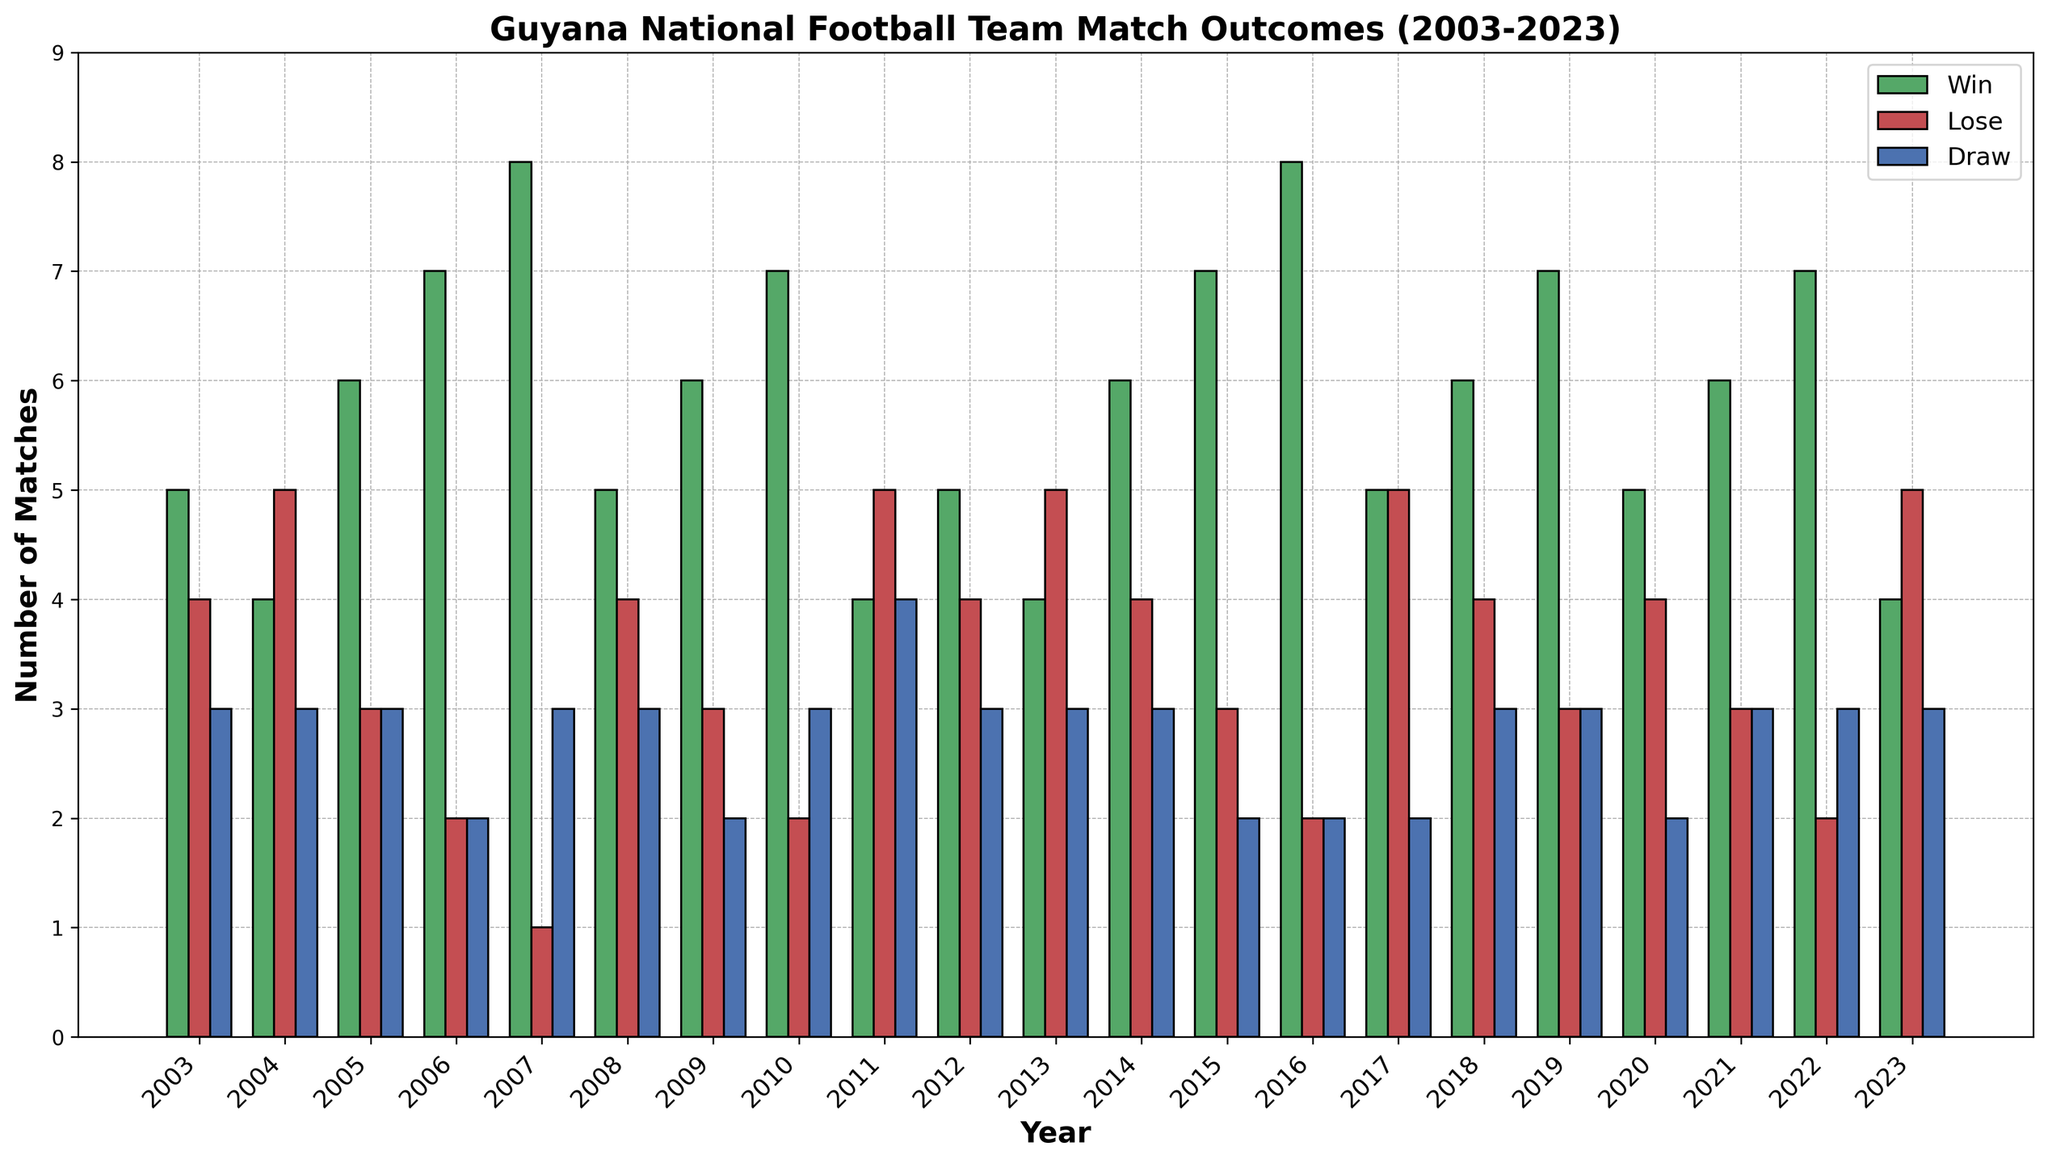What year did the Guyana national football team achieve the highest number of wins? By visually examining the green bars in the histogram, we see that the tallest green bar appears in the years 2007, 2016, and 2022, each representing 8 wins.
Answer: 2007, 2016, 2022 Which year had the highest number of losses for the Guyana national football team? By looking at the red bars in the histogram, the tallest red bars are seen in the years 2004, 2011, 2013, 2017, and 2023, where each year shows 5 losses.
Answer: 2004, 2011, 2013, 2017, 2023 In which year did the Guyana national football team have the most matches ending in a draw? By examining the height of the blue bars, the year 2011 displays the tallest blue bar with 4 draws.
Answer: 2011 What is the total number of matches played by the Guyana national football team in 2019 (sum of wins, losses, and draws)? The green bar shows 7 wins, the red bar shows 3 losses, and the blue bar shows 3 draws. Adding these gives 7 + 3 + 3 = 13 matches.
Answer: 13 Compare the number of wins in 2010 and 2011. Which year had more wins? In the histogram, the green bar for 2010 shows 7 wins, while the green bar for 2011 shows 4 wins. Therefore, 2010 had more wins.
Answer: 2010 What is the average number of losses per year between 2003 and 2023? Sum all the losses from 2003 to 2023: 4+5+3+2+1+4+3+2+5+4+5+4+3+2+5+4+3+4+3+2+5 = 72. Then divide by the number of years (21). 72 / 21 ≈ 3.43.
Answer: Approx. 3.43 What is the difference between the total number of draws in 2008 and 2020? The blue bar for 2008 shows 3 draws, and the blue bar for 2020 shows 2 draws. Subtracting these numbers gives 3 - 2 = 1.
Answer: 1 How many years had exactly 6 wins? Counting the number of years with green bars reaching 6 wins, we find such years in 2005, 2009, 2014, 2018, and 2021 – a total of 5 years.
Answer: 5 What is the combined number of draws in 2007 and 2023? The blue bar for 2007 shows 3 draws, and the blue bar for 2023 also shows 3 draws. Adding these together gives 3 + 3 = 6.
Answer: 6 In which year did the Guyana national football team achieve the same number of wins, losses, and draws? Visually inspecting the histogram, the year 2003 shows green, red, and blue bars each at 5, 4, and 3 respectively, and thus no year had identical numbers. Therefore, such a year does not exist.
Answer: None 